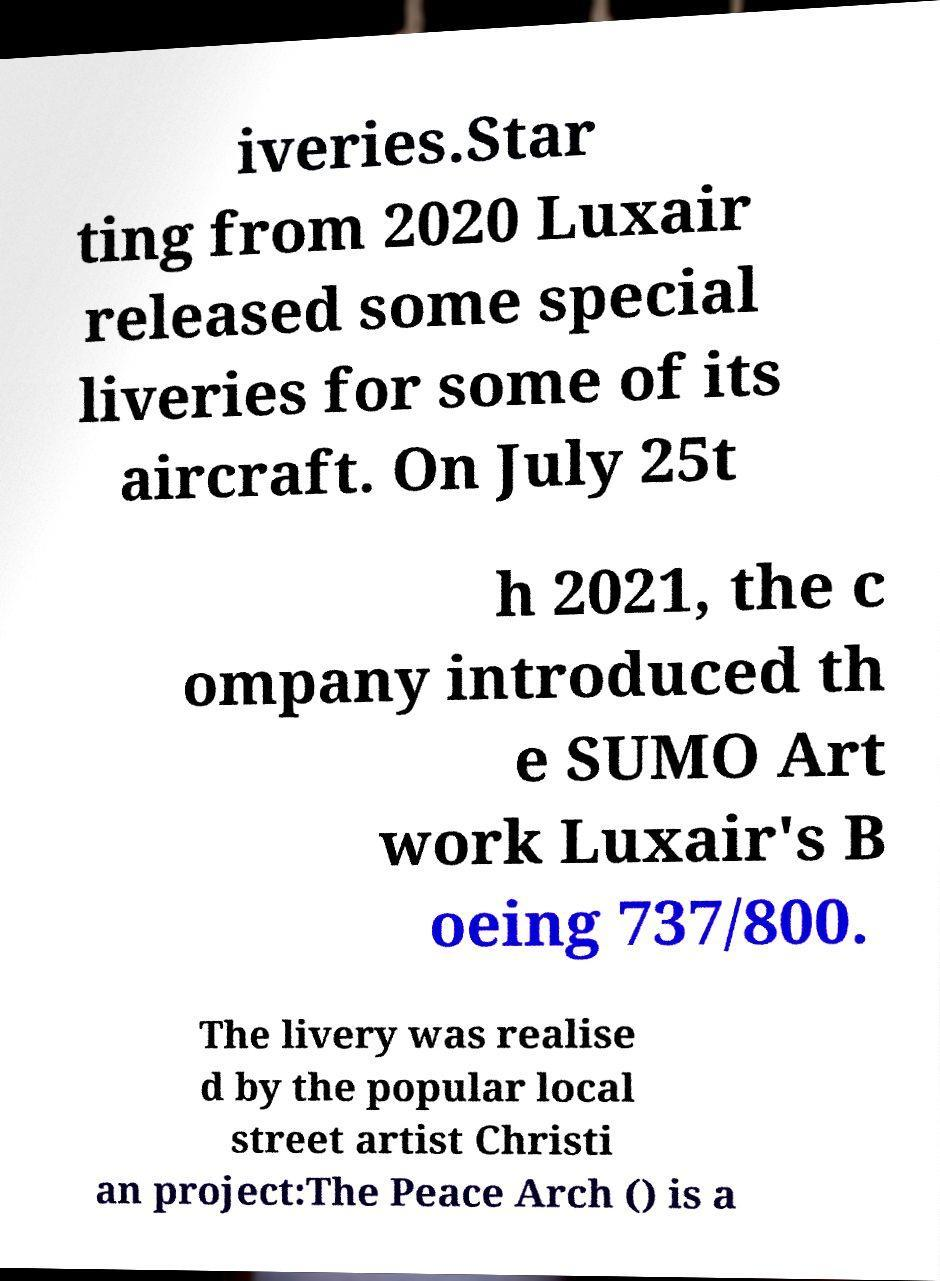Please identify and transcribe the text found in this image. iveries.Star ting from 2020 Luxair released some special liveries for some of its aircraft. On July 25t h 2021, the c ompany introduced th e SUMO Art work Luxair's B oeing 737/800. The livery was realise d by the popular local street artist Christi an project:The Peace Arch () is a 